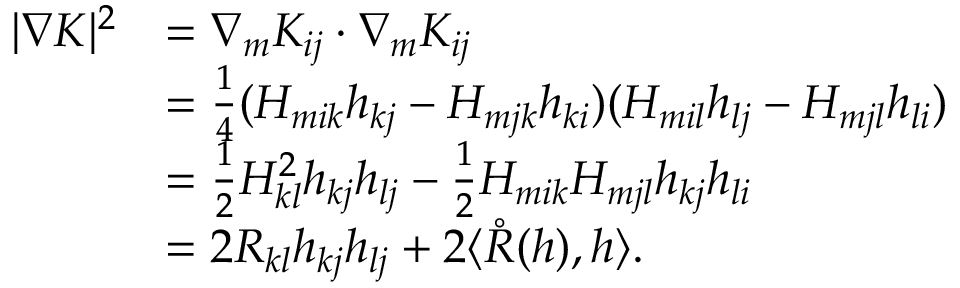Convert formula to latex. <formula><loc_0><loc_0><loc_500><loc_500>\begin{array} { r l } { | \nabla K | ^ { 2 } } & { = \nabla _ { m } K _ { i j } \cdot \nabla _ { m } K _ { i j } } \\ & { = \frac { 1 } { 4 } ( H _ { m i k } h _ { k j } - H _ { m j k } h _ { k i } ) ( H _ { m i l } h _ { l j } - H _ { m j l } h _ { l i } ) } \\ & { = \frac { 1 } { 2 } H _ { k l } ^ { 2 } h _ { k j } h _ { l j } - \frac { 1 } { 2 } H _ { m i k } H _ { m j l } h _ { k j } h _ { l i } } \\ & { = 2 R _ { k l } h _ { k j } h _ { l j } + 2 \langle \mathring { R } ( h ) , h \rangle . } \end{array}</formula> 